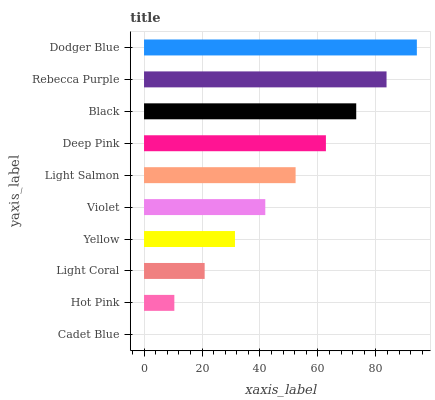Is Cadet Blue the minimum?
Answer yes or no. Yes. Is Dodger Blue the maximum?
Answer yes or no. Yes. Is Hot Pink the minimum?
Answer yes or no. No. Is Hot Pink the maximum?
Answer yes or no. No. Is Hot Pink greater than Cadet Blue?
Answer yes or no. Yes. Is Cadet Blue less than Hot Pink?
Answer yes or no. Yes. Is Cadet Blue greater than Hot Pink?
Answer yes or no. No. Is Hot Pink less than Cadet Blue?
Answer yes or no. No. Is Light Salmon the high median?
Answer yes or no. Yes. Is Violet the low median?
Answer yes or no. Yes. Is Yellow the high median?
Answer yes or no. No. Is Light Coral the low median?
Answer yes or no. No. 